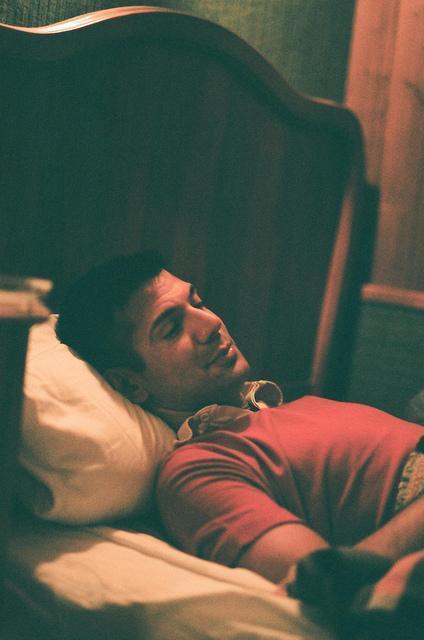How many cats are there?
Give a very brief answer. 0. 